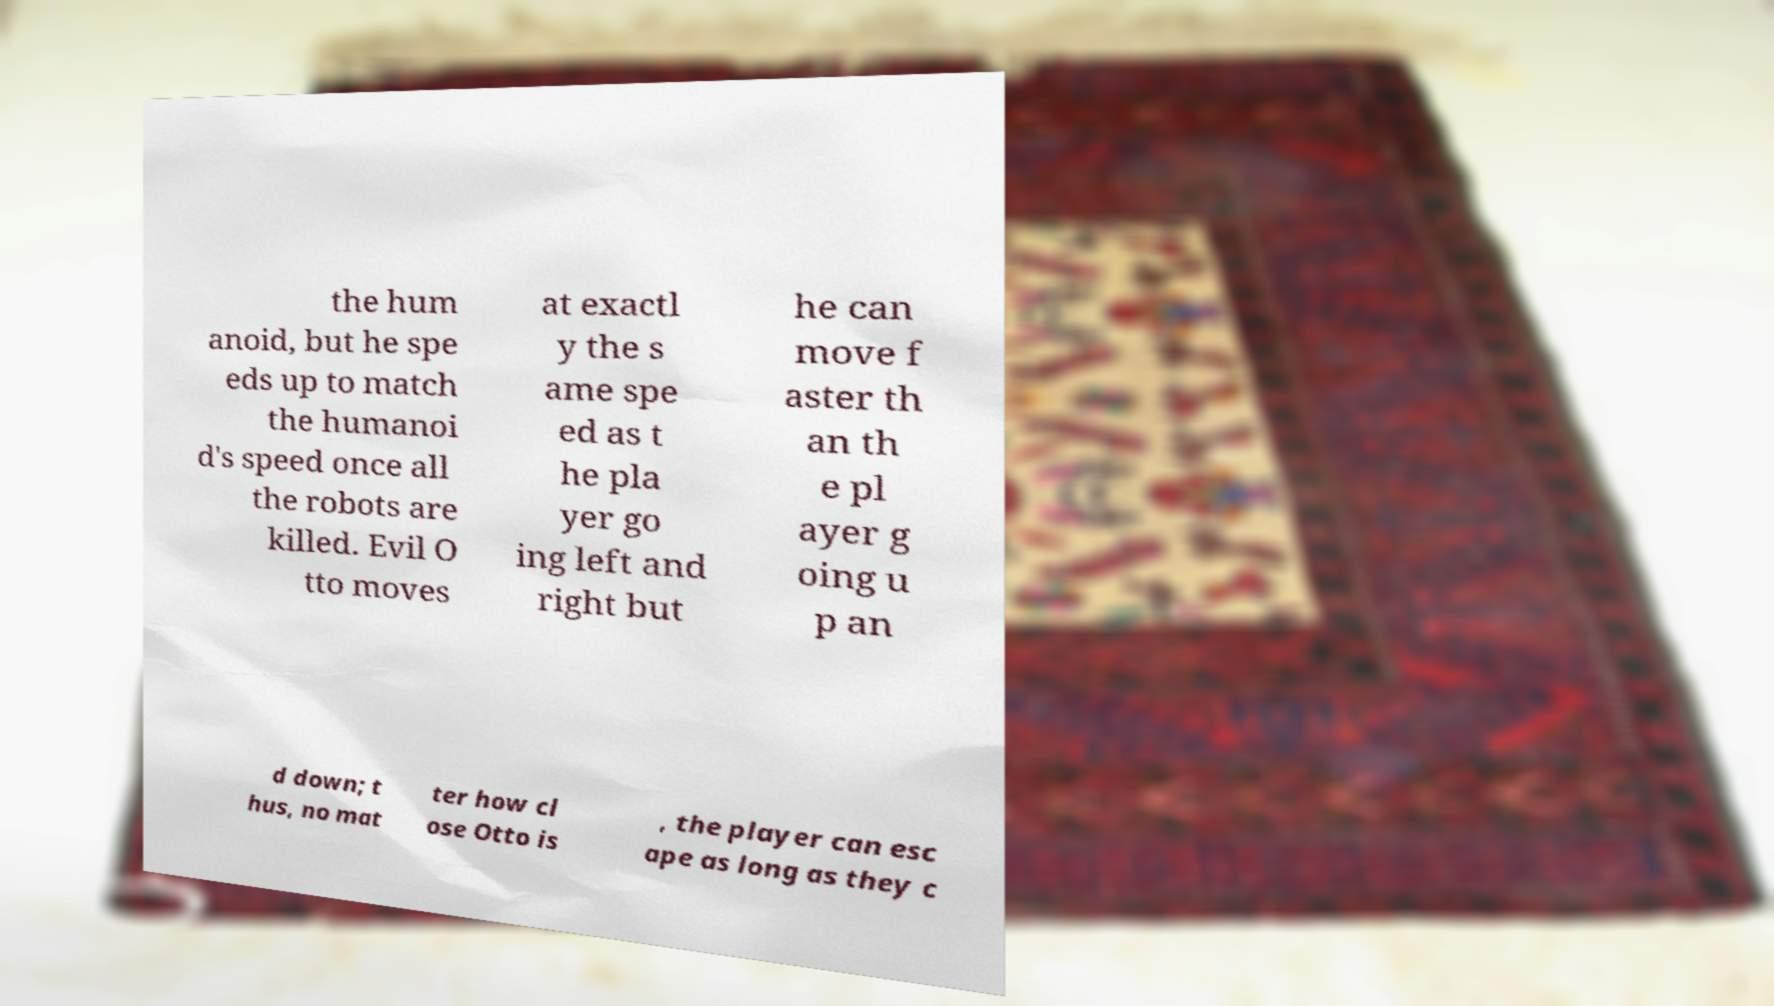Could you assist in decoding the text presented in this image and type it out clearly? the hum anoid, but he spe eds up to match the humanoi d's speed once all the robots are killed. Evil O tto moves at exactl y the s ame spe ed as t he pla yer go ing left and right but he can move f aster th an th e pl ayer g oing u p an d down; t hus, no mat ter how cl ose Otto is , the player can esc ape as long as they c 